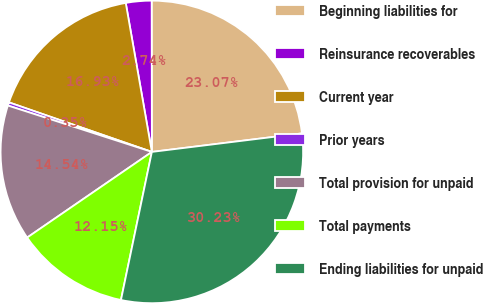Convert chart to OTSL. <chart><loc_0><loc_0><loc_500><loc_500><pie_chart><fcel>Beginning liabilities for<fcel>Reinsurance recoverables<fcel>Current year<fcel>Prior years<fcel>Total provision for unpaid<fcel>Total payments<fcel>Ending liabilities for unpaid<nl><fcel>23.07%<fcel>2.74%<fcel>16.93%<fcel>0.35%<fcel>14.54%<fcel>12.15%<fcel>30.23%<nl></chart> 